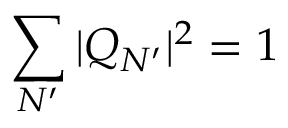Convert formula to latex. <formula><loc_0><loc_0><loc_500><loc_500>\sum _ { N ^ { \prime } } | Q _ { N ^ { \prime } } | ^ { 2 } = 1</formula> 